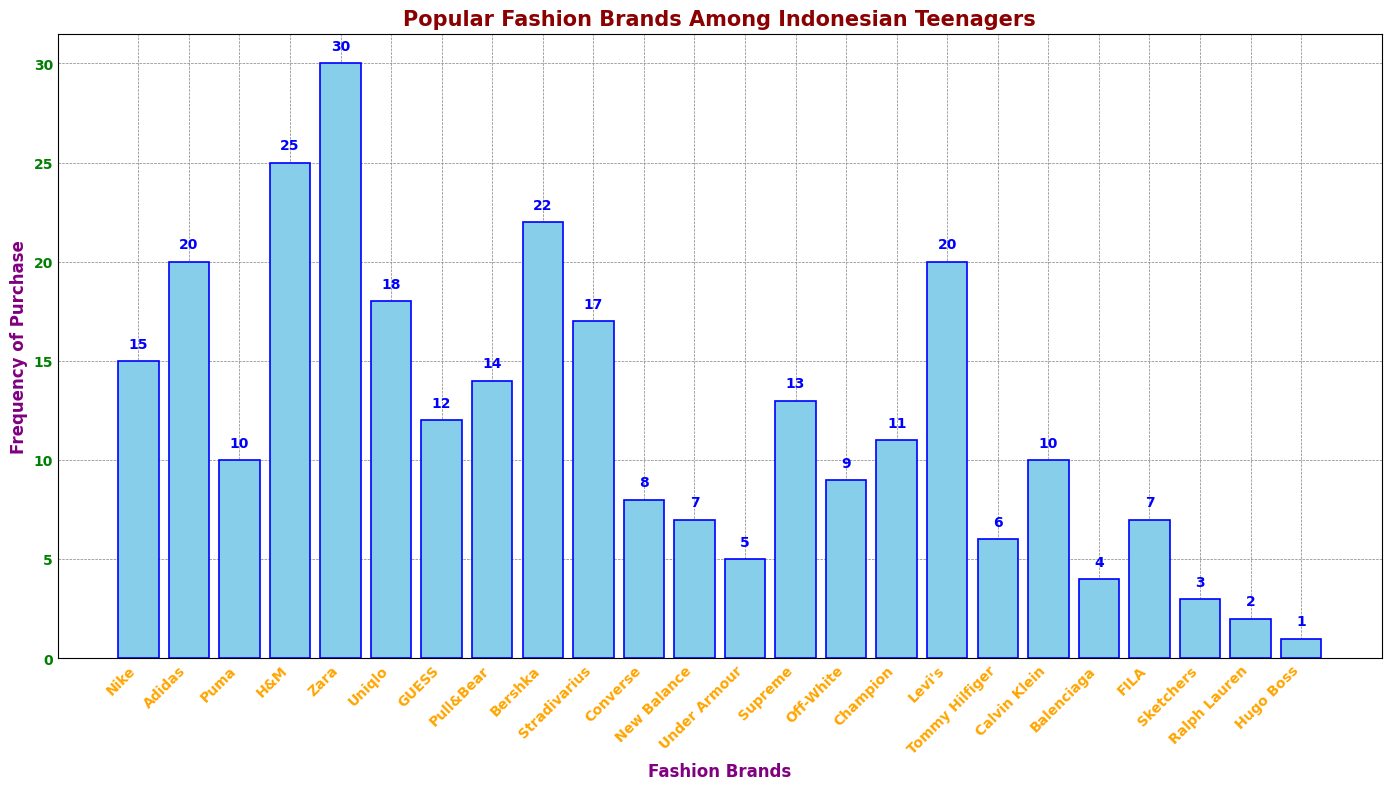Which brand has the highest frequency of purchase? Zara has the highest bar which indicates it has the highest frequency of purchase among all brands.
Answer: Zara Which brand has the lowest frequency of purchase? Hugo Boss has the shortest bar, which means it has the lowest frequency of purchase.
Answer: Hugo Boss How many brands have a frequency of purchase higher than 20? By counting the bars with a height greater than 20, we find Zara, H&M, and Bershka. There are 3 such brands.
Answer: 3 Which brand is more popular: Nike or Uniqlo? Uniqlo's bar is taller than Nike's bar, indicating Uniqlo is more frequently purchased.
Answer: Uniqlo What is the total frequency of purchase for brands with purchase frequency less than 10? Summing the frequencies of Converse, New Balance, Under Armour, Off-White, Tommy Hilfiger, Balenciaga, FILA, Sketchers, Ralph Lauren, and Hugo Boss: 8 + 7 + 5 + 9 + 6 + 4 + 7 + 3 + 2 + 1 = 52
Answer: 52 What is the difference in frequency of purchase between the brands H&M and Supreme? The frequency for H&M is 25, and for Supreme, it is 13. The difference is 25 - 13 = 12
Answer: 12 Are there more brands with a purchase frequency above or below 10? By counting, there are 10 brands with a frequency above 10 and 14 brands with a frequency below 10. There are more brands with a frequency below 10.
Answer: Below 10 What is the average frequency of purchase for Adidas, Nike, and Puma? Sum their frequencies: 20 (Adidas) + 15 (Nike) + 10 (Puma) = 45. Divide by the number of brands (3): 45 / 3 = 15
Answer: 15 